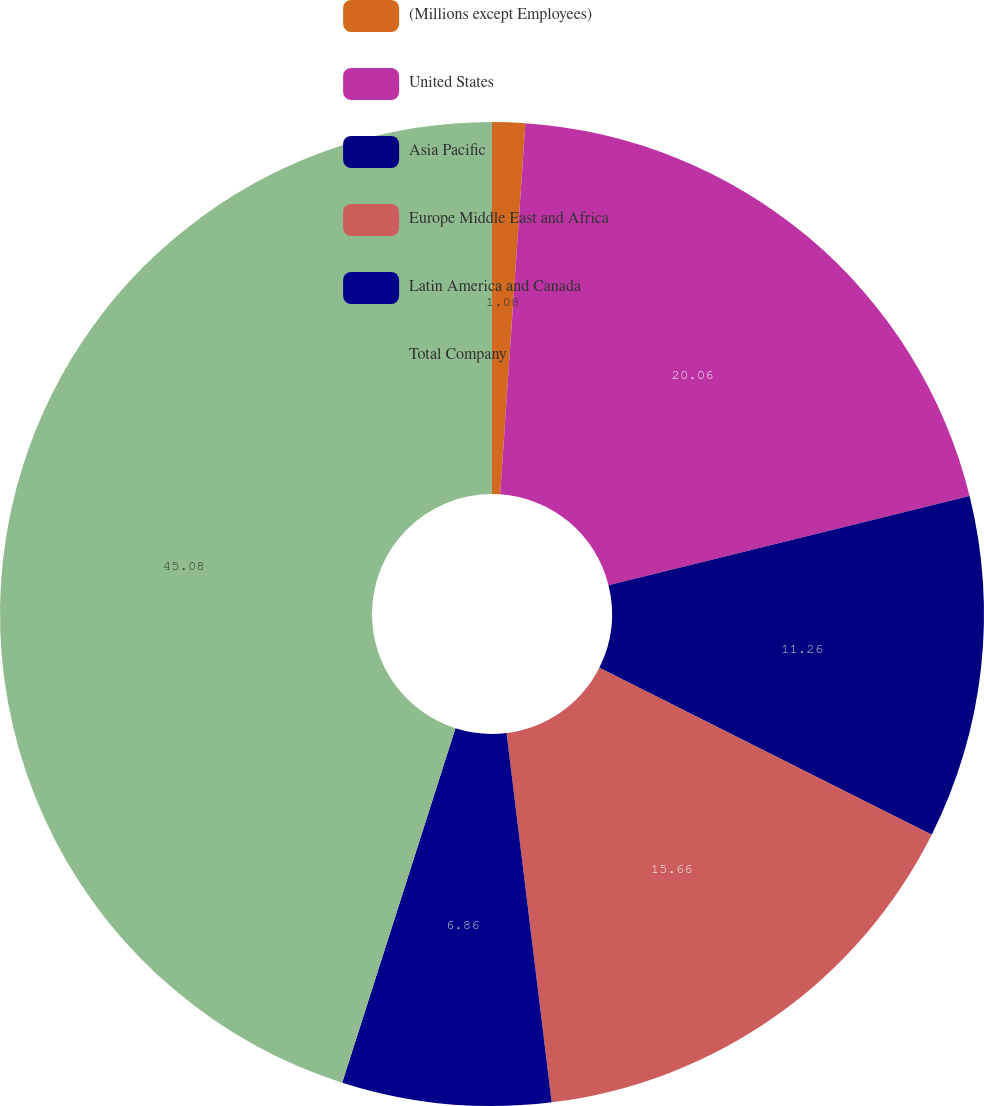<chart> <loc_0><loc_0><loc_500><loc_500><pie_chart><fcel>(Millions except Employees)<fcel>United States<fcel>Asia Pacific<fcel>Europe Middle East and Africa<fcel>Latin America and Canada<fcel>Total Company<nl><fcel>1.08%<fcel>20.06%<fcel>11.26%<fcel>15.66%<fcel>6.86%<fcel>45.07%<nl></chart> 